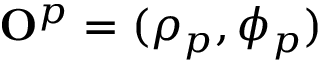<formula> <loc_0><loc_0><loc_500><loc_500>{ O } ^ { p } = ( \rho _ { p } , \phi _ { p } )</formula> 